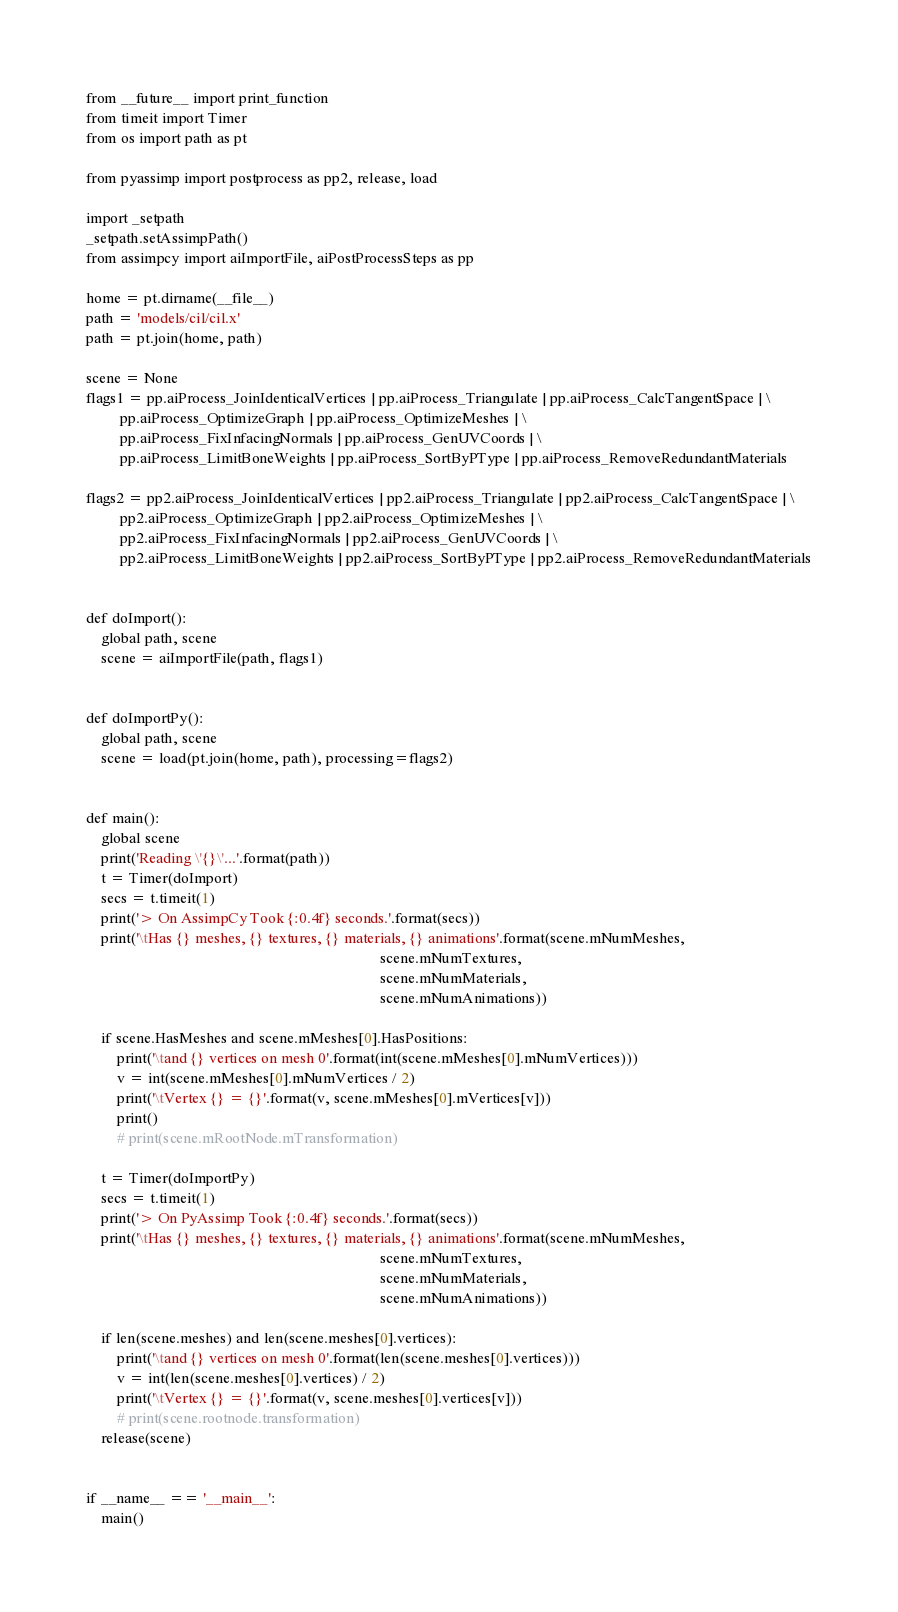Convert code to text. <code><loc_0><loc_0><loc_500><loc_500><_Python_>from __future__ import print_function
from timeit import Timer
from os import path as pt

from pyassimp import postprocess as pp2, release, load

import _setpath
_setpath.setAssimpPath()
from assimpcy import aiImportFile, aiPostProcessSteps as pp

home = pt.dirname(__file__)
path = 'models/cil/cil.x'
path = pt.join(home, path)

scene = None
flags1 = pp.aiProcess_JoinIdenticalVertices | pp.aiProcess_Triangulate | pp.aiProcess_CalcTangentSpace | \
         pp.aiProcess_OptimizeGraph | pp.aiProcess_OptimizeMeshes | \
         pp.aiProcess_FixInfacingNormals | pp.aiProcess_GenUVCoords | \
         pp.aiProcess_LimitBoneWeights | pp.aiProcess_SortByPType | pp.aiProcess_RemoveRedundantMaterials

flags2 = pp2.aiProcess_JoinIdenticalVertices | pp2.aiProcess_Triangulate | pp2.aiProcess_CalcTangentSpace | \
         pp2.aiProcess_OptimizeGraph | pp2.aiProcess_OptimizeMeshes | \
         pp2.aiProcess_FixInfacingNormals | pp2.aiProcess_GenUVCoords | \
         pp2.aiProcess_LimitBoneWeights | pp2.aiProcess_SortByPType | pp2.aiProcess_RemoveRedundantMaterials


def doImport():
    global path, scene
    scene = aiImportFile(path, flags1)


def doImportPy():
    global path, scene
    scene = load(pt.join(home, path), processing=flags2)


def main():
    global scene
    print('Reading \'{}\'...'.format(path))
    t = Timer(doImport)
    secs = t.timeit(1)
    print('> On AssimpCy Took {:0.4f} seconds.'.format(secs))
    print('\tHas {} meshes, {} textures, {} materials, {} animations'.format(scene.mNumMeshes,
                                                                             scene.mNumTextures,
                                                                             scene.mNumMaterials,
                                                                             scene.mNumAnimations))

    if scene.HasMeshes and scene.mMeshes[0].HasPositions:
        print('\tand {} vertices on mesh 0'.format(int(scene.mMeshes[0].mNumVertices)))
        v = int(scene.mMeshes[0].mNumVertices / 2)
        print('\tVertex {} = {}'.format(v, scene.mMeshes[0].mVertices[v]))
        print()
        # print(scene.mRootNode.mTransformation)

    t = Timer(doImportPy)
    secs = t.timeit(1)
    print('> On PyAssimp Took {:0.4f} seconds.'.format(secs))
    print('\tHas {} meshes, {} textures, {} materials, {} animations'.format(scene.mNumMeshes,
                                                                             scene.mNumTextures,
                                                                             scene.mNumMaterials,
                                                                             scene.mNumAnimations))

    if len(scene.meshes) and len(scene.meshes[0].vertices):
        print('\tand {} vertices on mesh 0'.format(len(scene.meshes[0].vertices)))
        v = int(len(scene.meshes[0].vertices) / 2)
        print('\tVertex {} = {}'.format(v, scene.meshes[0].vertices[v]))
        # print(scene.rootnode.transformation)
    release(scene)


if __name__ == '__main__':
    main()
</code> 